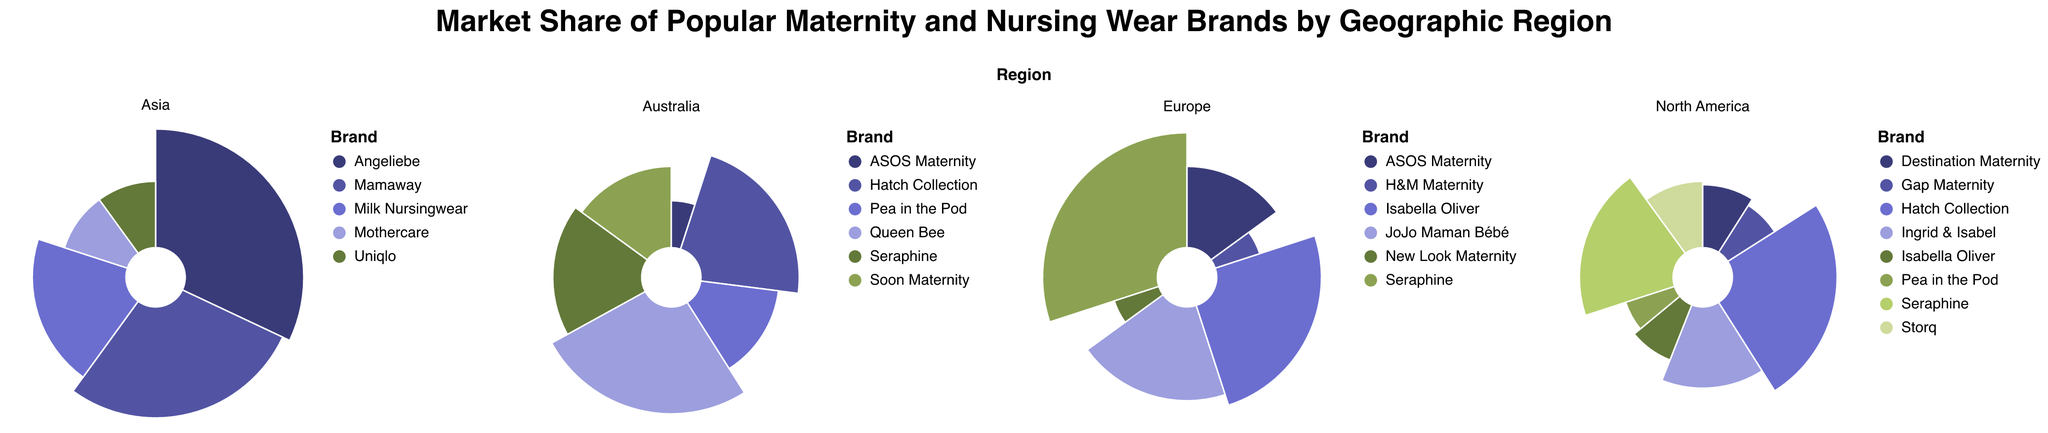What's the title of the figure? The title of the figure is displayed prominently at the top of the chart. It reads, "Market Share of Popular Maternity and Nursing Wear Brands by Geographic Region."
Answer: Market Share of Popular Maternity and Nursing Wear Brands by Geographic Region Which region has the highest market share for Seraphine? To determine this, we look at the subplots and identify the region where Seraphine has the largest segment in the chart. In Europe, Seraphine has a market share of 30%, which is higher than its market shares in North America (20%) and Australia (18%). Asia does not list Seraphine.
Answer: Europe What is the combined market share of Hatch Collection in North America and Australia? Hatch Collection has a market share of 0.25 in North America and 0.22 in Australia. Adding these two values together, 0.25 + 0.22, gives us the combined market share.
Answer: 0.47 Which brand has the smallest market share in Europe? By examining the Europe subplot, both H&M Maternity and New Look Maternity have the smallest market share, each with 0.05.
Answer: H&M Maternity and New Look Maternity Compare the market shares of Pea in the Pod in North America and Australia. Which region is greater? In North America, Pea in the Pod has a market share of 0.06. In Australia, it has a market share of 0.14. Therefore, Pea in the Pod has a greater market share in Australia than in North America.
Answer: Australia How does the market share of ASOS Maternity in Europe compare to its market share in Australia? In Europe, ASOS Maternity has a market share of 0.15, while in Australia, it has a market share of 0.05. Therefore, the market share in Europe is 0.10 higher than in Australia.
Answer: Europe has 0.10 higher What is the total market share of the top 2 brands in Asia? The top 2 brands in Asia are Angeliebe (0.32) and Mamaway (0.28). Adding these two values, we get 0.32 + 0.28 = 0.60.
Answer: 0.60 Which region has the highest variety of maternity and nursing wear brands? Count the number of unique brands for each region in the subplots. North America has 8 brands, Europe has 6 brands, Asia has 5 brands, and Australia has 6 brands. Therefore, North America has the highest variety.
Answer: North America Which brand appears in both the North America and Australia regions, and what are their respective market shares? Hatch Collection and Seraphine appear in both regions. Hatch Collection has a market share of 0.25 in North America and 0.22 in Australia. Seraphine has a market share of 0.20 in North America and 0.18 in Australia.
Answer: Hatch Collection (0.25, 0.22) and Seraphine (0.20, 0.18) What is the market share difference between the top brand in North America and the top brand in Asia? The top brand in North America is Hatch Collection with a market share of 0.25. The top brand in Asia is Angeliebe with a market share of 0.32. The difference is 0.32 - 0.25 = 0.07.
Answer: 0.07 